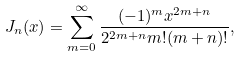Convert formula to latex. <formula><loc_0><loc_0><loc_500><loc_500>J _ { n } ( x ) = \sum _ { m = 0 } ^ { \infty } \frac { ( - 1 ) ^ { m } x ^ { 2 m + n } } { 2 ^ { 2 m + n } m ! ( m + n ) ! } ,</formula> 